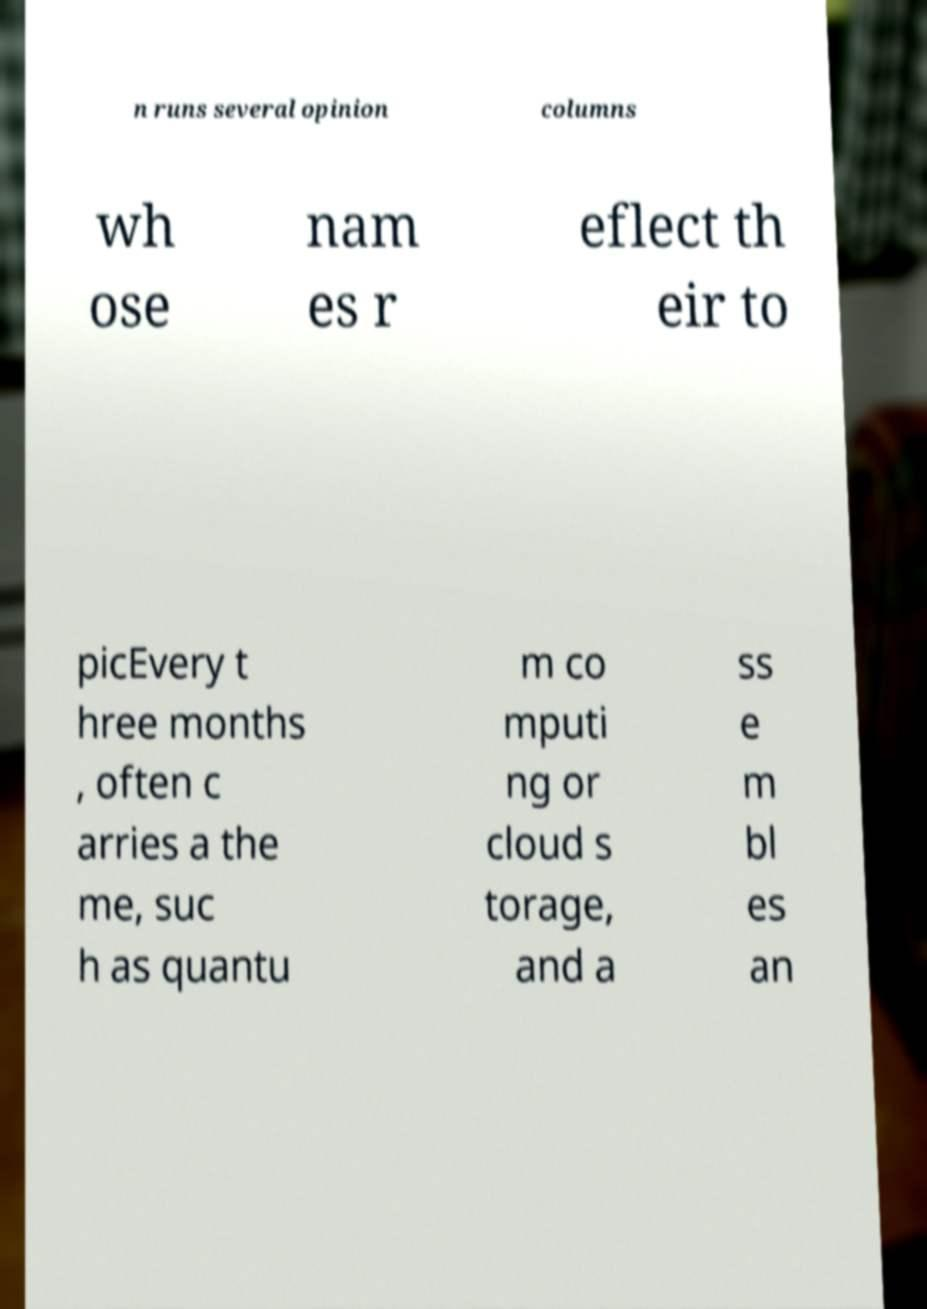Could you extract and type out the text from this image? n runs several opinion columns wh ose nam es r eflect th eir to picEvery t hree months , often c arries a the me, suc h as quantu m co mputi ng or cloud s torage, and a ss e m bl es an 